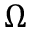Convert formula to latex. <formula><loc_0><loc_0><loc_500><loc_500>\Omega</formula> 